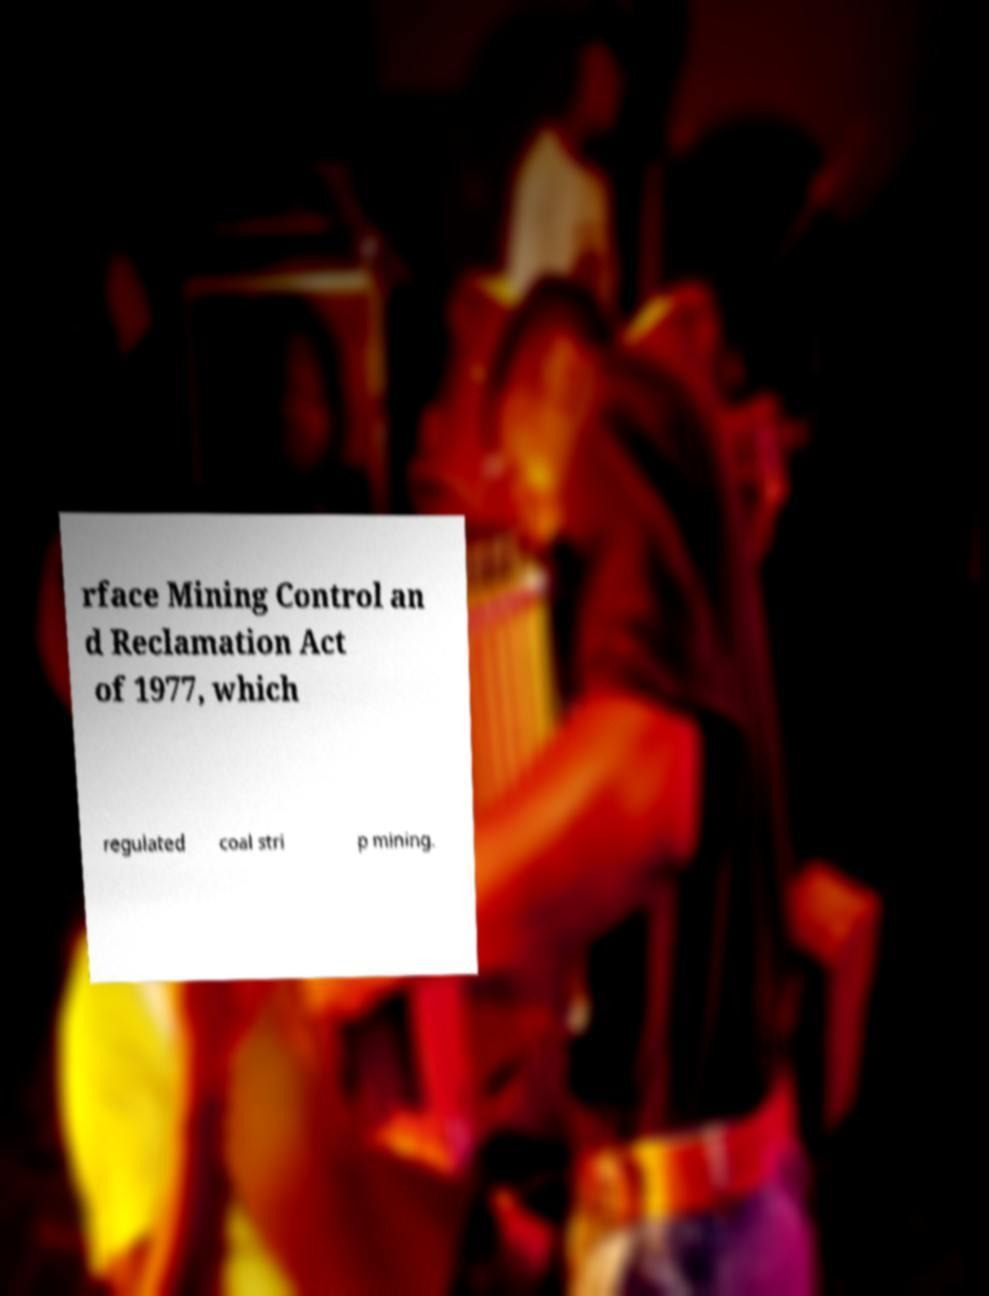There's text embedded in this image that I need extracted. Can you transcribe it verbatim? rface Mining Control an d Reclamation Act of 1977, which regulated coal stri p mining. 